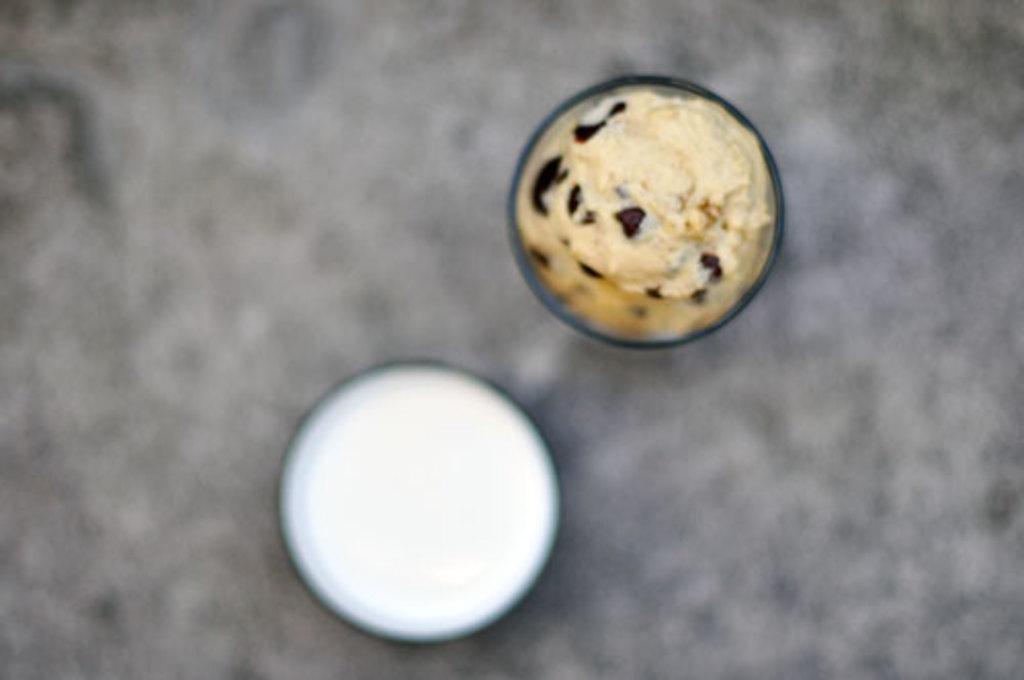Can you describe this image briefly? In this image we can see food places in the glass bowls. 